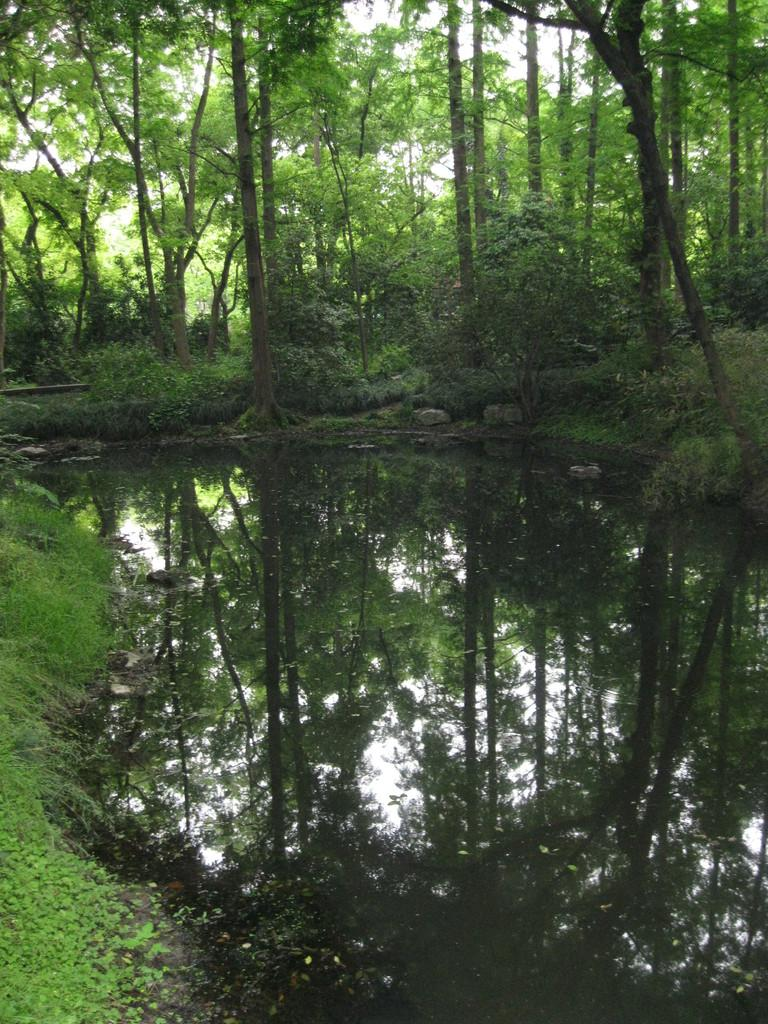What is located in the middle of the image? There is a small water canal in the middle of the image. What type of vegetation can be seen in the image? There are tall trees visible in the image. What type of cap is the sister wearing in the image? There is no sister or cap present in the image; it only features a small water canal and tall trees. 